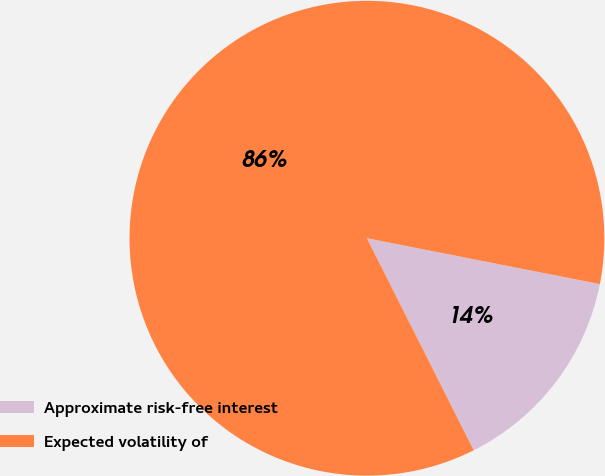Convert chart. <chart><loc_0><loc_0><loc_500><loc_500><pie_chart><fcel>Approximate risk-free interest<fcel>Expected volatility of<nl><fcel>14.48%<fcel>85.52%<nl></chart> 